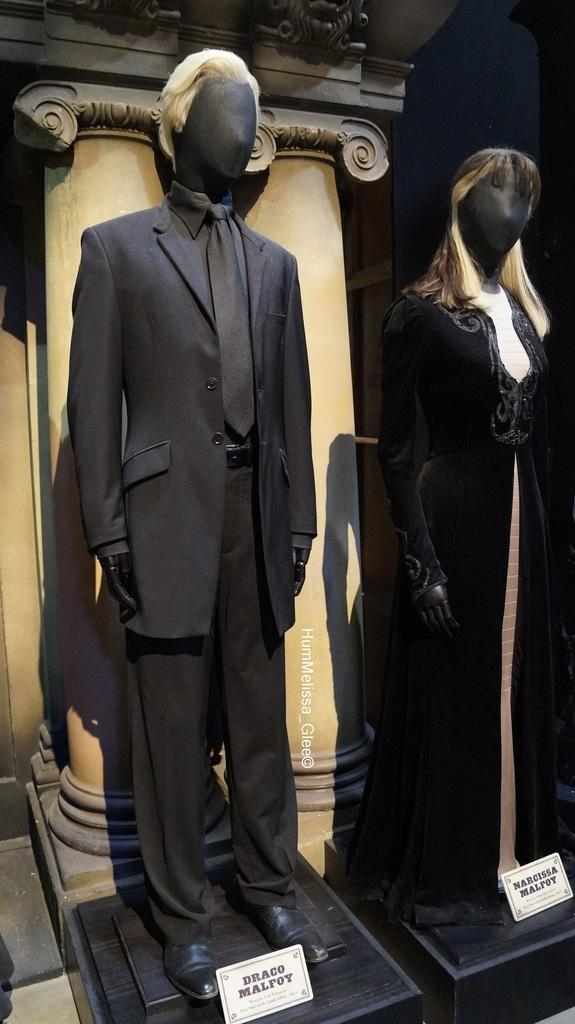What can be seen in the image? There are two statues in the image. What are the statues wearing? The statues are wearing black clothes. What else can be seen in the image besides the statues? There are other objects in the background of the image. What type of mint is growing near the statues in the image? There is no mint present in the image; it only features two statues wearing black clothes and other objects in the background. 